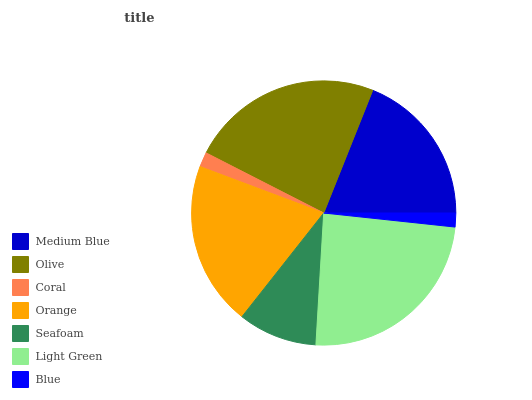Is Blue the minimum?
Answer yes or no. Yes. Is Light Green the maximum?
Answer yes or no. Yes. Is Olive the minimum?
Answer yes or no. No. Is Olive the maximum?
Answer yes or no. No. Is Olive greater than Medium Blue?
Answer yes or no. Yes. Is Medium Blue less than Olive?
Answer yes or no. Yes. Is Medium Blue greater than Olive?
Answer yes or no. No. Is Olive less than Medium Blue?
Answer yes or no. No. Is Medium Blue the high median?
Answer yes or no. Yes. Is Medium Blue the low median?
Answer yes or no. Yes. Is Coral the high median?
Answer yes or no. No. Is Seafoam the low median?
Answer yes or no. No. 